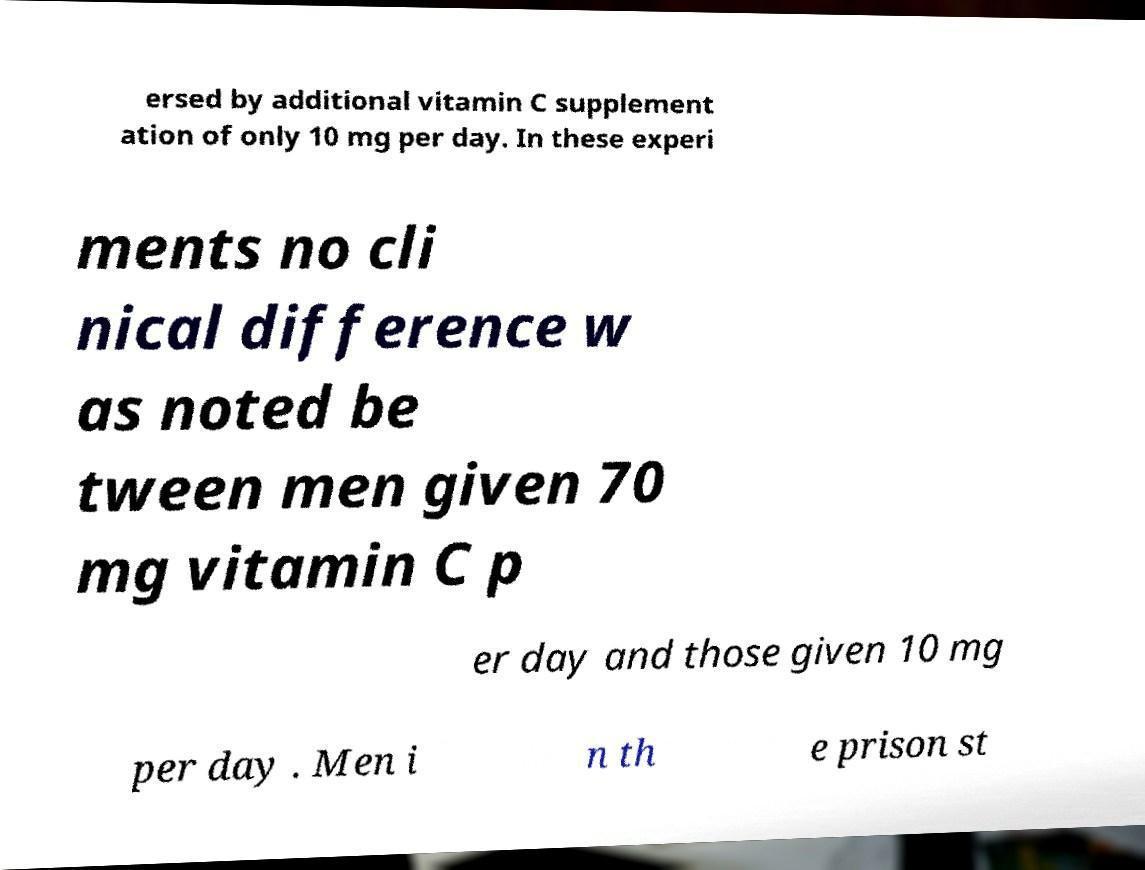Could you extract and type out the text from this image? ersed by additional vitamin C supplement ation of only 10 mg per day. In these experi ments no cli nical difference w as noted be tween men given 70 mg vitamin C p er day and those given 10 mg per day . Men i n th e prison st 